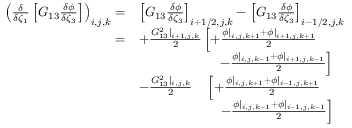<formula> <loc_0><loc_0><loc_500><loc_500>\begin{array} { r l } { \left ( \frac { \delta } { \delta \zeta _ { 1 } } \left [ G _ { 1 3 } \frac { \delta \phi } { \delta \zeta _ { 3 } } \right ] \right ) _ { i , j , k } = } & { \left [ G _ { 1 3 } \frac { \delta \phi } { \delta \zeta _ { 3 } } \right ] _ { i + 1 / 2 , j , k } - \left [ G _ { 1 3 } \frac { \delta \phi } { \delta \zeta _ { 3 } } \right ] _ { i - 1 / 2 , j , k } } \\ { = } & { + \frac { G _ { 1 3 } ^ { 2 } | _ { i + 1 , j , k } } { 2 } \left [ + \frac { \phi | _ { i , j , k + 1 } + \phi | _ { i + 1 , j , k + 1 } } { 2 } } \\ & { \quad - \frac { \phi | _ { i , j , k - 1 } + \phi | _ { i + 1 , j , k - 1 } } { 2 } \right ] } \\ & { - \frac { G _ { 1 3 } ^ { 2 } | _ { i , j , k } } { 2 } \quad \left [ + \frac { \phi | _ { i , j , k + 1 } + \phi | _ { i - 1 , j , k + 1 } } { 2 } } \\ & { \quad \, - \frac { \phi | _ { i , j , k - 1 } + \phi | _ { i - 1 , j , k - 1 } } { 2 } \right ] } \end{array}</formula> 